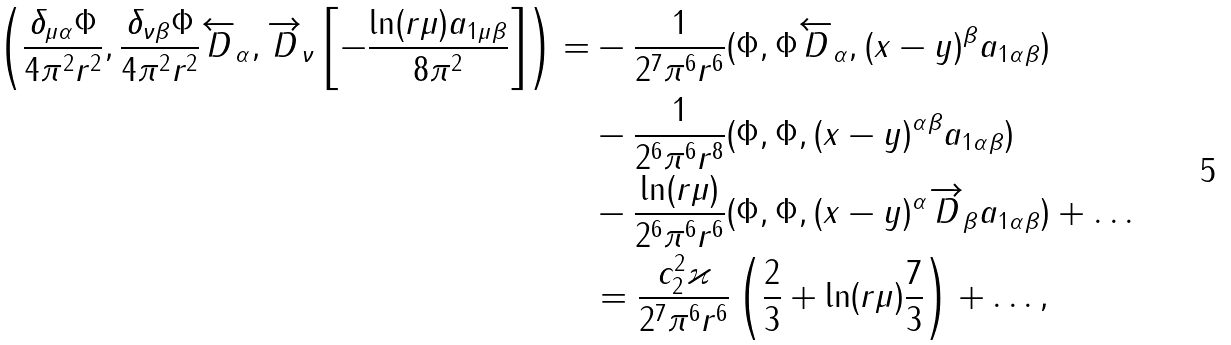<formula> <loc_0><loc_0><loc_500><loc_500>\left ( \frac { \delta _ { \mu \alpha } \Phi } { 4 \pi ^ { 2 } r ^ { 2 } } , \frac { \delta _ { \nu \beta } \Phi } { 4 \pi ^ { 2 } r ^ { 2 } } \overleftarrow { D } _ { \alpha } , \overrightarrow { D } _ { \nu } \left [ - \frac { \ln ( r \mu ) a _ { 1 \mu \beta } } { 8 \pi ^ { 2 } } \right ] \right ) = & - \frac { 1 } { 2 ^ { 7 } \pi ^ { 6 } r ^ { 6 } } ( \Phi , \Phi \overleftarrow { D } _ { \alpha } , ( x - y ) ^ { \beta } a _ { 1 \alpha \beta } ) \\ & - \frac { 1 } { 2 ^ { 6 } \pi ^ { 6 } r ^ { 8 } } ( \Phi , \Phi , ( x - y ) ^ { \alpha \beta } a _ { 1 \alpha \beta } ) \\ & - \frac { \ln ( r \mu ) } { 2 ^ { 6 } \pi ^ { 6 } r ^ { 6 } } ( \Phi , \Phi , ( x - y ) ^ { \alpha } \overrightarrow { D } _ { \beta } a _ { 1 \alpha \beta } ) + \dots \\ & = \frac { c _ { 2 } ^ { 2 } \varkappa } { 2 ^ { 7 } \pi ^ { 6 } r ^ { 6 } } \left ( \frac { 2 } { 3 } + \ln ( r \mu ) \frac { 7 } { 3 } \right ) + \dots ,</formula> 